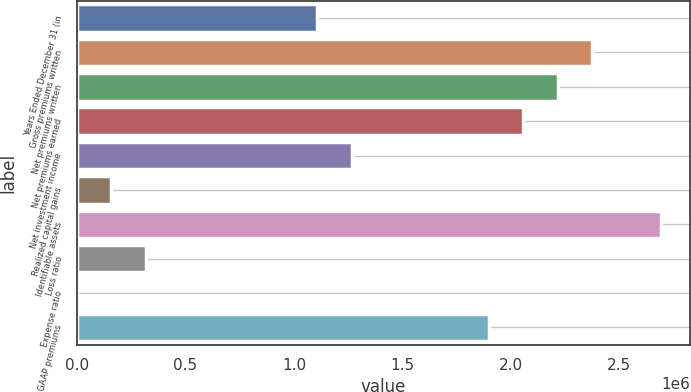Convert chart to OTSL. <chart><loc_0><loc_0><loc_500><loc_500><bar_chart><fcel>Years Ended December 31 (in<fcel>Gross premiums written<fcel>Net premiums written<fcel>Net premiums earned<fcel>Net investment income<fcel>Realized capital gains<fcel>Identifiable assets<fcel>Loss ratio<fcel>Expense ratio<fcel>GAAP premiums<nl><fcel>1.10813e+06<fcel>2.37454e+06<fcel>2.21624e+06<fcel>2.05793e+06<fcel>1.26643e+06<fcel>158321<fcel>2.69114e+06<fcel>316622<fcel>19.6<fcel>1.89963e+06<nl></chart> 